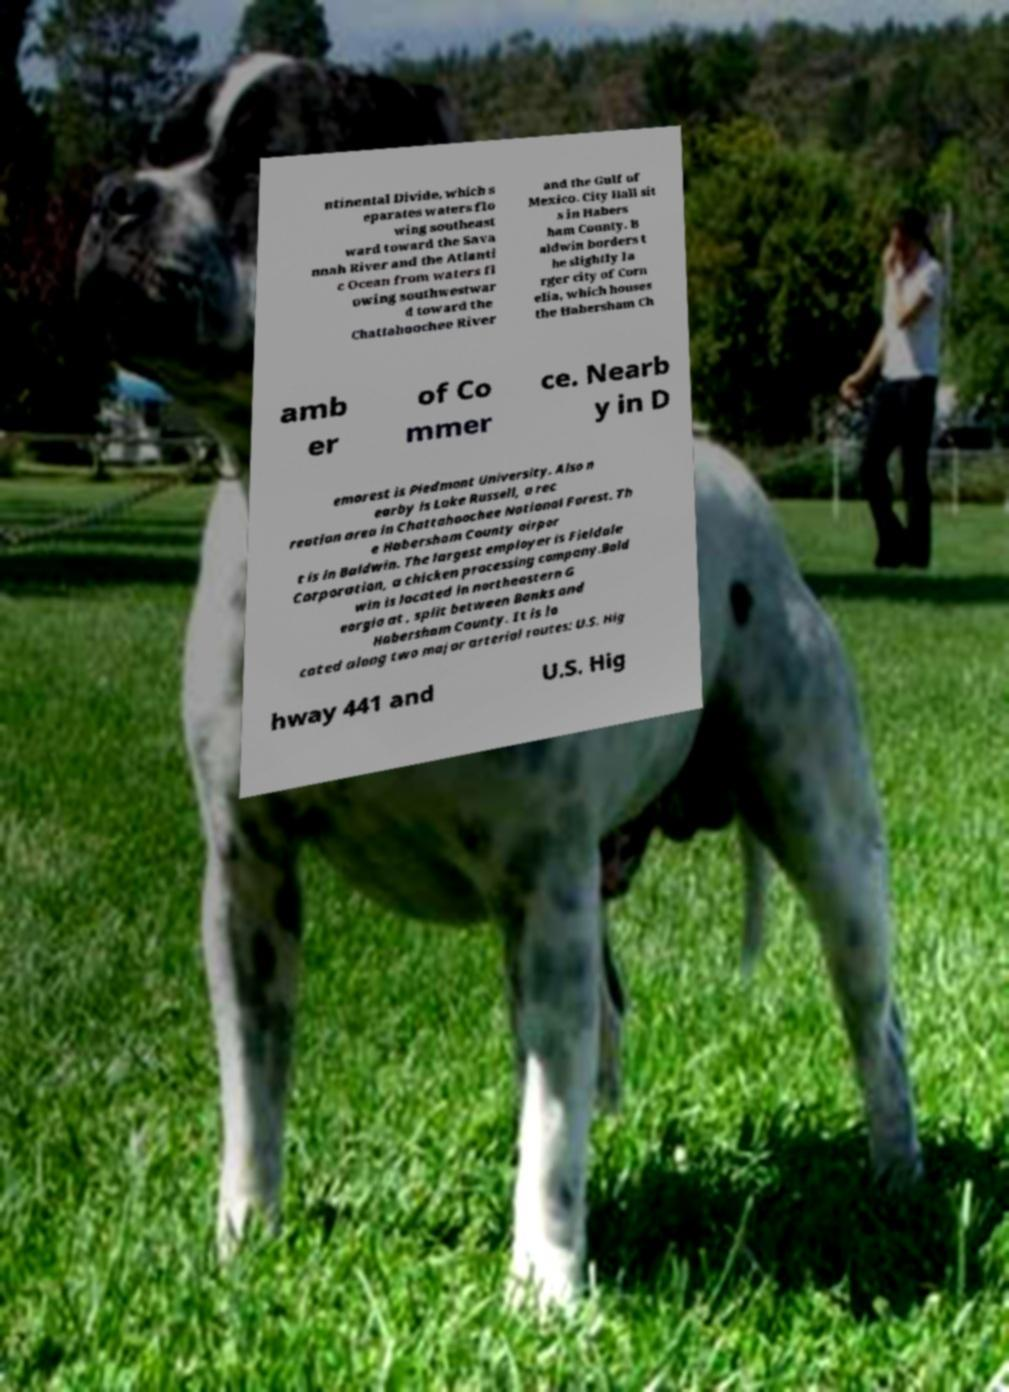Can you accurately transcribe the text from the provided image for me? ntinental Divide, which s eparates waters flo wing southeast ward toward the Sava nnah River and the Atlanti c Ocean from waters fl owing southwestwar d toward the Chattahoochee River and the Gulf of Mexico. City Hall sit s in Habers ham County. B aldwin borders t he slightly la rger city of Corn elia, which houses the Habersham Ch amb er of Co mmer ce. Nearb y in D emorest is Piedmont University. Also n earby is Lake Russell, a rec reation area in Chattahoochee National Forest. Th e Habersham County airpor t is in Baldwin. The largest employer is Fieldale Corporation, a chicken processing company.Bald win is located in northeastern G eorgia at , split between Banks and Habersham County. It is lo cated along two major arterial routes: U.S. Hig hway 441 and U.S. Hig 